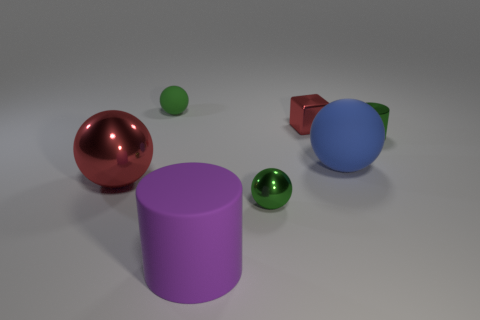The big thing in front of the red metal object on the left side of the tiny metal object that is in front of the tiny green shiny cylinder is what color?
Keep it short and to the point. Purple. What number of other things are the same color as the tiny metal block?
Make the answer very short. 1. How many metal things are either big blue balls or green things?
Your response must be concise. 2. Do the tiny sphere behind the tiny green shiny cylinder and the small ball in front of the large red object have the same color?
Your response must be concise. Yes. What size is the other matte object that is the same shape as the tiny green matte thing?
Your answer should be compact. Large. Are there more tiny things behind the tiny shiny cube than big red cylinders?
Ensure brevity in your answer.  Yes. Is the tiny green sphere that is in front of the green matte object made of the same material as the tiny red cube?
Make the answer very short. Yes. There is a matte ball to the right of the small ball on the left side of the metal ball right of the purple matte thing; what size is it?
Give a very brief answer. Large. The cylinder that is the same material as the tiny red thing is what size?
Offer a very short reply. Small. There is a thing that is in front of the big red ball and behind the big rubber cylinder; what is its color?
Give a very brief answer. Green. 